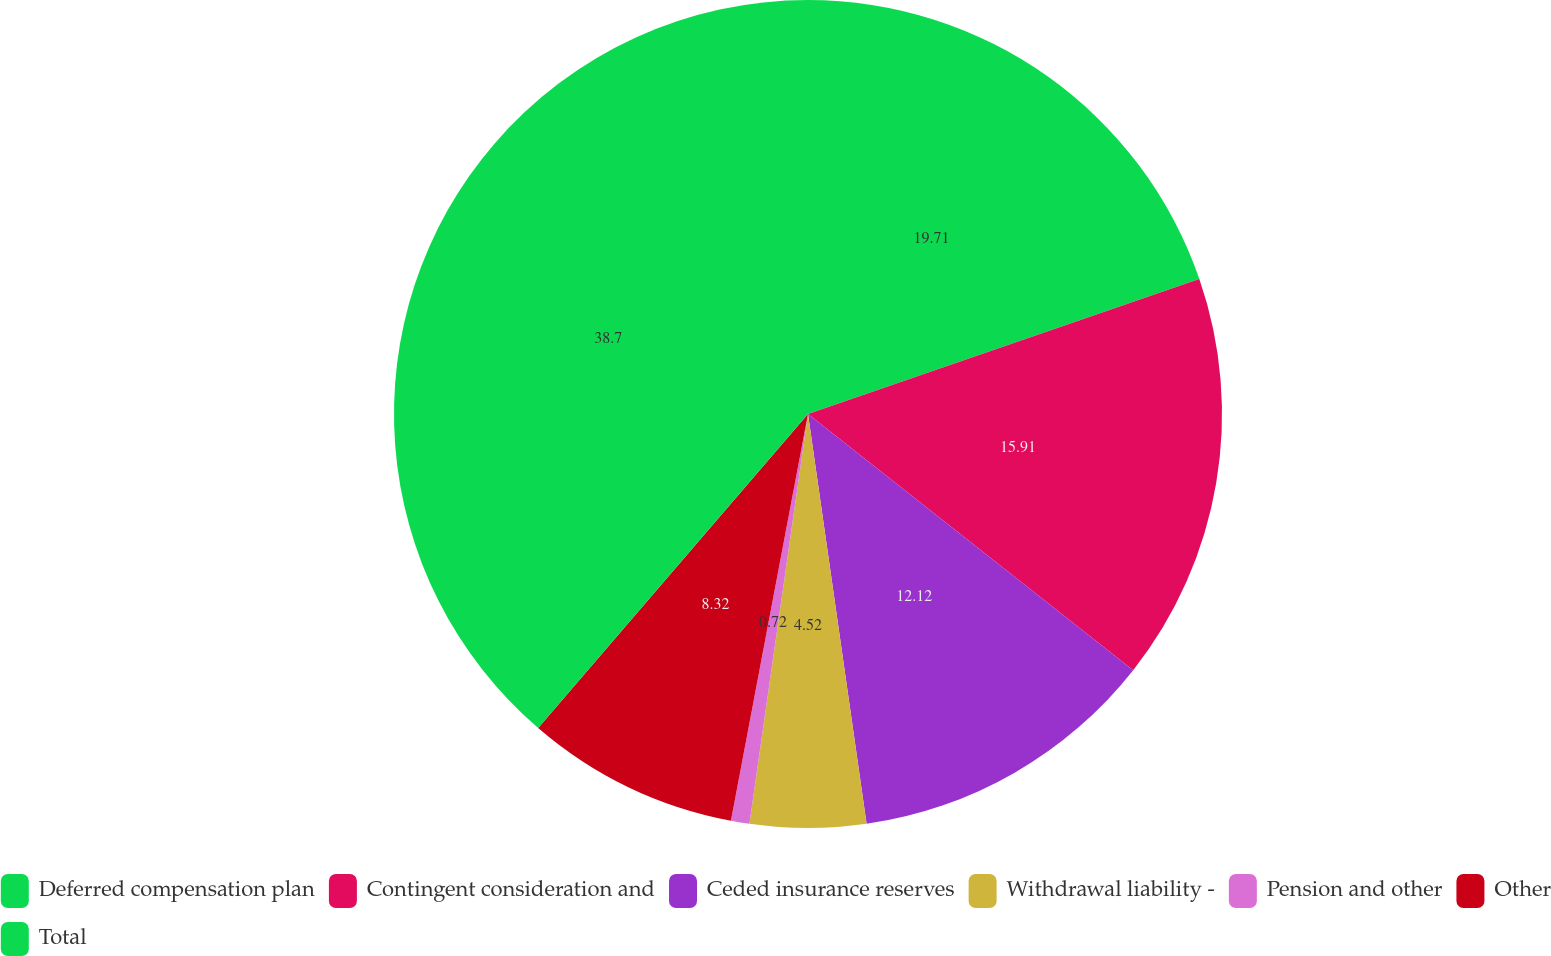Convert chart to OTSL. <chart><loc_0><loc_0><loc_500><loc_500><pie_chart><fcel>Deferred compensation plan<fcel>Contingent consideration and<fcel>Ceded insurance reserves<fcel>Withdrawal liability -<fcel>Pension and other<fcel>Other<fcel>Total<nl><fcel>19.71%<fcel>15.91%<fcel>12.12%<fcel>4.52%<fcel>0.72%<fcel>8.32%<fcel>38.7%<nl></chart> 